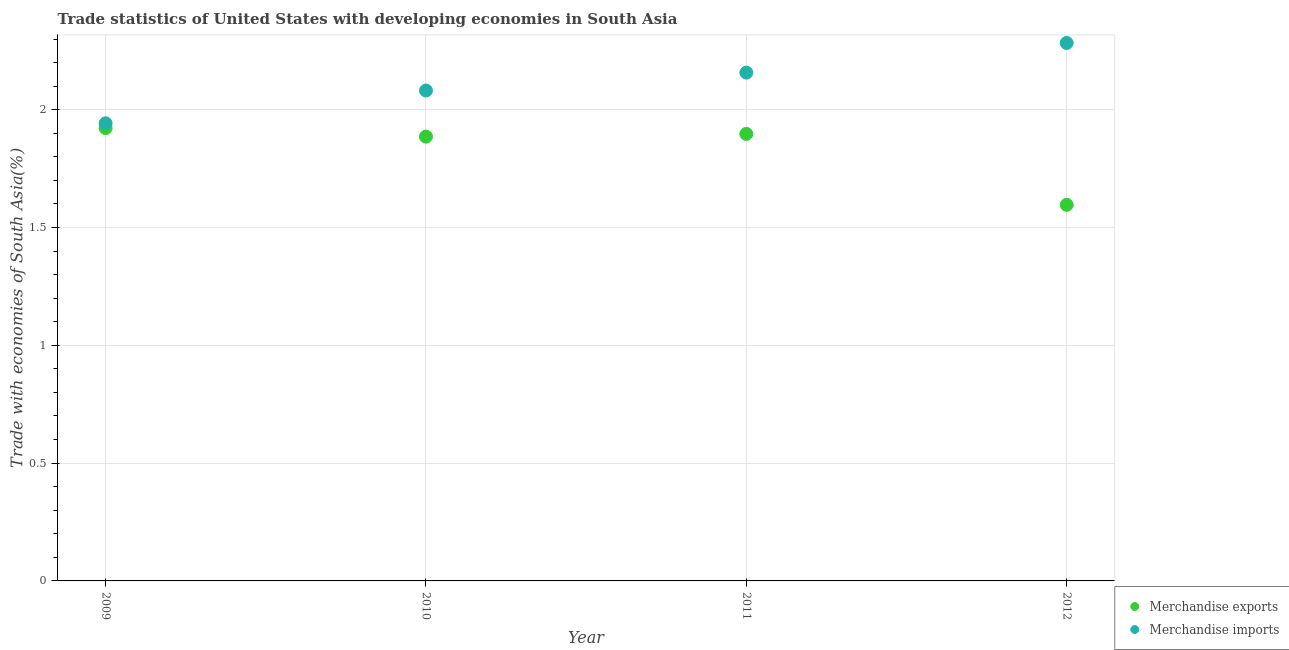Is the number of dotlines equal to the number of legend labels?
Provide a short and direct response. Yes. What is the merchandise exports in 2009?
Keep it short and to the point. 1.92. Across all years, what is the maximum merchandise exports?
Provide a succinct answer. 1.92. Across all years, what is the minimum merchandise imports?
Ensure brevity in your answer.  1.94. In which year was the merchandise exports minimum?
Keep it short and to the point. 2012. What is the total merchandise exports in the graph?
Give a very brief answer. 7.3. What is the difference between the merchandise imports in 2010 and that in 2011?
Make the answer very short. -0.08. What is the difference between the merchandise exports in 2010 and the merchandise imports in 2009?
Keep it short and to the point. -0.06. What is the average merchandise imports per year?
Make the answer very short. 2.12. In the year 2010, what is the difference between the merchandise exports and merchandise imports?
Make the answer very short. -0.2. In how many years, is the merchandise exports greater than 1.1 %?
Your response must be concise. 4. What is the ratio of the merchandise exports in 2011 to that in 2012?
Make the answer very short. 1.19. What is the difference between the highest and the second highest merchandise exports?
Provide a succinct answer. 0.02. What is the difference between the highest and the lowest merchandise imports?
Offer a terse response. 0.34. Does the merchandise exports monotonically increase over the years?
Offer a very short reply. No. Is the merchandise exports strictly less than the merchandise imports over the years?
Offer a very short reply. Yes. How many years are there in the graph?
Your answer should be very brief. 4. Are the values on the major ticks of Y-axis written in scientific E-notation?
Provide a short and direct response. No. Does the graph contain grids?
Make the answer very short. Yes. How are the legend labels stacked?
Your response must be concise. Vertical. What is the title of the graph?
Ensure brevity in your answer.  Trade statistics of United States with developing economies in South Asia. Does "% of GNI" appear as one of the legend labels in the graph?
Offer a very short reply. No. What is the label or title of the Y-axis?
Make the answer very short. Trade with economies of South Asia(%). What is the Trade with economies of South Asia(%) in Merchandise exports in 2009?
Make the answer very short. 1.92. What is the Trade with economies of South Asia(%) in Merchandise imports in 2009?
Make the answer very short. 1.94. What is the Trade with economies of South Asia(%) of Merchandise exports in 2010?
Make the answer very short. 1.89. What is the Trade with economies of South Asia(%) in Merchandise imports in 2010?
Offer a very short reply. 2.08. What is the Trade with economies of South Asia(%) in Merchandise exports in 2011?
Give a very brief answer. 1.9. What is the Trade with economies of South Asia(%) of Merchandise imports in 2011?
Your answer should be compact. 2.16. What is the Trade with economies of South Asia(%) in Merchandise exports in 2012?
Offer a very short reply. 1.6. What is the Trade with economies of South Asia(%) in Merchandise imports in 2012?
Give a very brief answer. 2.28. Across all years, what is the maximum Trade with economies of South Asia(%) in Merchandise exports?
Your answer should be compact. 1.92. Across all years, what is the maximum Trade with economies of South Asia(%) in Merchandise imports?
Offer a very short reply. 2.28. Across all years, what is the minimum Trade with economies of South Asia(%) of Merchandise exports?
Provide a succinct answer. 1.6. Across all years, what is the minimum Trade with economies of South Asia(%) of Merchandise imports?
Make the answer very short. 1.94. What is the total Trade with economies of South Asia(%) of Merchandise exports in the graph?
Your answer should be very brief. 7.3. What is the total Trade with economies of South Asia(%) of Merchandise imports in the graph?
Your answer should be compact. 8.46. What is the difference between the Trade with economies of South Asia(%) of Merchandise exports in 2009 and that in 2010?
Provide a short and direct response. 0.04. What is the difference between the Trade with economies of South Asia(%) of Merchandise imports in 2009 and that in 2010?
Your answer should be compact. -0.14. What is the difference between the Trade with economies of South Asia(%) of Merchandise exports in 2009 and that in 2011?
Give a very brief answer. 0.02. What is the difference between the Trade with economies of South Asia(%) in Merchandise imports in 2009 and that in 2011?
Your response must be concise. -0.22. What is the difference between the Trade with economies of South Asia(%) in Merchandise exports in 2009 and that in 2012?
Provide a short and direct response. 0.33. What is the difference between the Trade with economies of South Asia(%) of Merchandise imports in 2009 and that in 2012?
Make the answer very short. -0.34. What is the difference between the Trade with economies of South Asia(%) of Merchandise exports in 2010 and that in 2011?
Offer a very short reply. -0.01. What is the difference between the Trade with economies of South Asia(%) of Merchandise imports in 2010 and that in 2011?
Provide a succinct answer. -0.08. What is the difference between the Trade with economies of South Asia(%) of Merchandise exports in 2010 and that in 2012?
Your response must be concise. 0.29. What is the difference between the Trade with economies of South Asia(%) of Merchandise imports in 2010 and that in 2012?
Your response must be concise. -0.2. What is the difference between the Trade with economies of South Asia(%) of Merchandise exports in 2011 and that in 2012?
Ensure brevity in your answer.  0.3. What is the difference between the Trade with economies of South Asia(%) in Merchandise imports in 2011 and that in 2012?
Ensure brevity in your answer.  -0.13. What is the difference between the Trade with economies of South Asia(%) in Merchandise exports in 2009 and the Trade with economies of South Asia(%) in Merchandise imports in 2010?
Make the answer very short. -0.16. What is the difference between the Trade with economies of South Asia(%) of Merchandise exports in 2009 and the Trade with economies of South Asia(%) of Merchandise imports in 2011?
Keep it short and to the point. -0.24. What is the difference between the Trade with economies of South Asia(%) in Merchandise exports in 2009 and the Trade with economies of South Asia(%) in Merchandise imports in 2012?
Your answer should be very brief. -0.36. What is the difference between the Trade with economies of South Asia(%) in Merchandise exports in 2010 and the Trade with economies of South Asia(%) in Merchandise imports in 2011?
Make the answer very short. -0.27. What is the difference between the Trade with economies of South Asia(%) in Merchandise exports in 2010 and the Trade with economies of South Asia(%) in Merchandise imports in 2012?
Provide a short and direct response. -0.4. What is the difference between the Trade with economies of South Asia(%) of Merchandise exports in 2011 and the Trade with economies of South Asia(%) of Merchandise imports in 2012?
Your answer should be very brief. -0.39. What is the average Trade with economies of South Asia(%) of Merchandise exports per year?
Keep it short and to the point. 1.83. What is the average Trade with economies of South Asia(%) in Merchandise imports per year?
Offer a terse response. 2.12. In the year 2009, what is the difference between the Trade with economies of South Asia(%) in Merchandise exports and Trade with economies of South Asia(%) in Merchandise imports?
Your answer should be compact. -0.02. In the year 2010, what is the difference between the Trade with economies of South Asia(%) of Merchandise exports and Trade with economies of South Asia(%) of Merchandise imports?
Ensure brevity in your answer.  -0.2. In the year 2011, what is the difference between the Trade with economies of South Asia(%) in Merchandise exports and Trade with economies of South Asia(%) in Merchandise imports?
Your response must be concise. -0.26. In the year 2012, what is the difference between the Trade with economies of South Asia(%) in Merchandise exports and Trade with economies of South Asia(%) in Merchandise imports?
Give a very brief answer. -0.69. What is the ratio of the Trade with economies of South Asia(%) of Merchandise exports in 2009 to that in 2010?
Ensure brevity in your answer.  1.02. What is the ratio of the Trade with economies of South Asia(%) in Merchandise imports in 2009 to that in 2010?
Ensure brevity in your answer.  0.93. What is the ratio of the Trade with economies of South Asia(%) of Merchandise imports in 2009 to that in 2011?
Provide a succinct answer. 0.9. What is the ratio of the Trade with economies of South Asia(%) in Merchandise exports in 2009 to that in 2012?
Give a very brief answer. 1.2. What is the ratio of the Trade with economies of South Asia(%) in Merchandise imports in 2009 to that in 2012?
Provide a succinct answer. 0.85. What is the ratio of the Trade with economies of South Asia(%) of Merchandise imports in 2010 to that in 2011?
Make the answer very short. 0.96. What is the ratio of the Trade with economies of South Asia(%) in Merchandise exports in 2010 to that in 2012?
Your answer should be very brief. 1.18. What is the ratio of the Trade with economies of South Asia(%) of Merchandise imports in 2010 to that in 2012?
Provide a short and direct response. 0.91. What is the ratio of the Trade with economies of South Asia(%) in Merchandise exports in 2011 to that in 2012?
Offer a terse response. 1.19. What is the ratio of the Trade with economies of South Asia(%) in Merchandise imports in 2011 to that in 2012?
Offer a very short reply. 0.94. What is the difference between the highest and the second highest Trade with economies of South Asia(%) in Merchandise exports?
Make the answer very short. 0.02. What is the difference between the highest and the second highest Trade with economies of South Asia(%) of Merchandise imports?
Provide a succinct answer. 0.13. What is the difference between the highest and the lowest Trade with economies of South Asia(%) of Merchandise exports?
Ensure brevity in your answer.  0.33. What is the difference between the highest and the lowest Trade with economies of South Asia(%) in Merchandise imports?
Give a very brief answer. 0.34. 